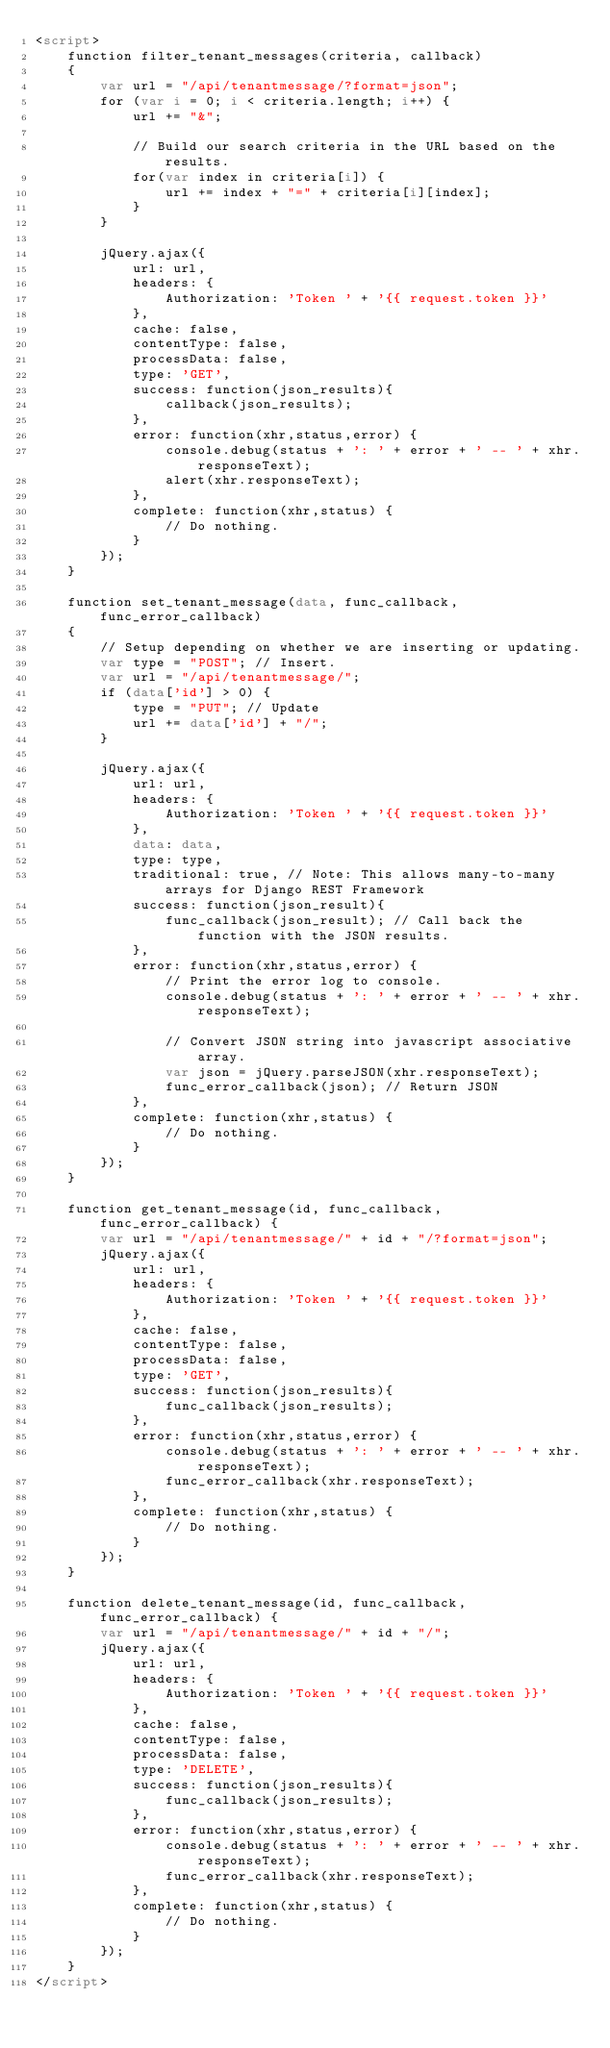<code> <loc_0><loc_0><loc_500><loc_500><_HTML_><script>
    function filter_tenant_messages(criteria, callback)
    {
        var url = "/api/tenantmessage/?format=json";
        for (var i = 0; i < criteria.length; i++) {
            url += "&";

            // Build our search criteria in the URL based on the results.
            for(var index in criteria[i]) {
                url += index + "=" + criteria[i][index];
            }
        }

        jQuery.ajax({
            url: url,
            headers: {
                Authorization: 'Token ' + '{{ request.token }}'
            },
            cache: false,
            contentType: false,
            processData: false,
            type: 'GET',
            success: function(json_results){
                callback(json_results);
            },
            error: function(xhr,status,error) {
                console.debug(status + ': ' + error + ' -- ' + xhr.responseText);
                alert(xhr.responseText);
            },
            complete: function(xhr,status) {
                // Do nothing.
            }
        });
    }

    function set_tenant_message(data, func_callback, func_error_callback)
    {
        // Setup depending on whether we are inserting or updating.
        var type = "POST"; // Insert.
        var url = "/api/tenantmessage/";
        if (data['id'] > 0) {
            type = "PUT"; // Update
            url += data['id'] + "/";
        }

        jQuery.ajax({
            url: url,
            headers: {
                Authorization: 'Token ' + '{{ request.token }}'
            },
            data: data,
            type: type,
            traditional: true, // Note: This allows many-to-many arrays for Django REST Framework
            success: function(json_result){
                func_callback(json_result); // Call back the function with the JSON results.
            },
            error: function(xhr,status,error) {
                // Print the error log to console.
                console.debug(status + ': ' + error + ' -- ' + xhr.responseText);

                // Convert JSON string into javascript associative array.
                var json = jQuery.parseJSON(xhr.responseText);
                func_error_callback(json); // Return JSON
            },
            complete: function(xhr,status) {
                // Do nothing.
            }
        });
    }

    function get_tenant_message(id, func_callback, func_error_callback) {
        var url = "/api/tenantmessage/" + id + "/?format=json";
        jQuery.ajax({
            url: url,
            headers: {
                Authorization: 'Token ' + '{{ request.token }}'
            },
            cache: false,
            contentType: false,
            processData: false,
            type: 'GET',
            success: function(json_results){
                func_callback(json_results);
            },
            error: function(xhr,status,error) {
                console.debug(status + ': ' + error + ' -- ' + xhr.responseText);
                func_error_callback(xhr.responseText);
            },
            complete: function(xhr,status) {
                // Do nothing.
            }
        });
    }

    function delete_tenant_message(id, func_callback, func_error_callback) {
        var url = "/api/tenantmessage/" + id + "/";
        jQuery.ajax({
            url: url,
            headers: {
                Authorization: 'Token ' + '{{ request.token }}'
            },
            cache: false,
            contentType: false,
            processData: false,
            type: 'DELETE',
            success: function(json_results){
                func_callback(json_results);
            },
            error: function(xhr,status,error) {
                console.debug(status + ': ' + error + ' -- ' + xhr.responseText);
                func_error_callback(xhr.responseText);
            },
            complete: function(xhr,status) {
                // Do nothing.
            }
        });
    }
</script>
</code> 